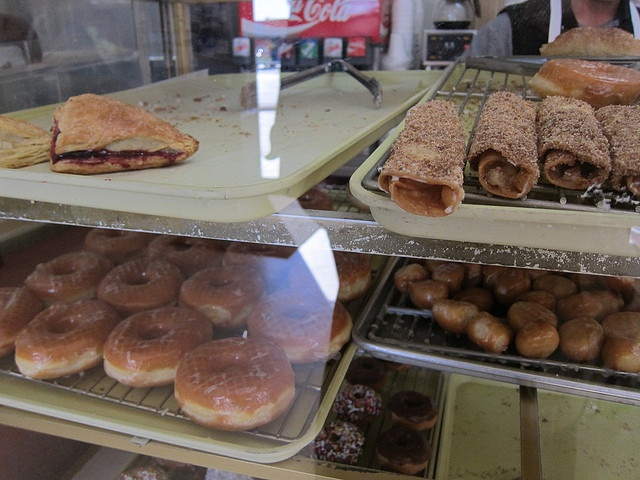Describe the objects in this image and their specific colors. I can see donut in gray, brown, and tan tones, donut in gray, maroon, and brown tones, donut in gray, maroon, and brown tones, donut in gray and black tones, and donut in gray tones in this image. 